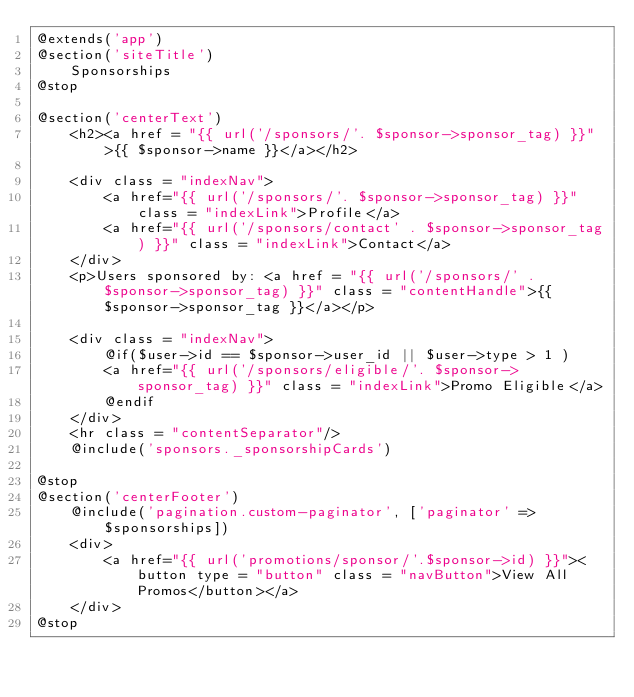Convert code to text. <code><loc_0><loc_0><loc_500><loc_500><_PHP_>@extends('app')
@section('siteTitle')
    Sponsorships
@stop

@section('centerText')
    <h2><a href = "{{ url('/sponsors/'. $sponsor->sponsor_tag) }}">{{ $sponsor->name }}</a></h2>

    <div class = "indexNav">
        <a href="{{ url('/sponsors/'. $sponsor->sponsor_tag) }}" class = "indexLink">Profile</a>
        <a href="{{ url('/sponsors/contact' . $sponsor->sponsor_tag) }}" class = "indexLink">Contact</a>
    </div>
    <p>Users sponsored by: <a href = "{{ url('/sponsors/' . $sponsor->sponsor_tag) }}" class = "contentHandle">{{ $sponsor->sponsor_tag }}</a></p>

    <div class = "indexNav">
        @if($user->id == $sponsor->user_id || $user->type > 1 )
        <a href="{{ url('/sponsors/eligible/'. $sponsor->sponsor_tag) }}" class = "indexLink">Promo Eligible</a>
        @endif
    </div>
    <hr class = "contentSeparator"/>
    @include('sponsors._sponsorshipCards')

@stop
@section('centerFooter')
    @include('pagination.custom-paginator', ['paginator' => $sponsorships])
    <div>
        <a href="{{ url('promotions/sponsor/'.$sponsor->id) }}"><button type = "button" class = "navButton">View All Promos</button></a>
    </div>
@stop


</code> 